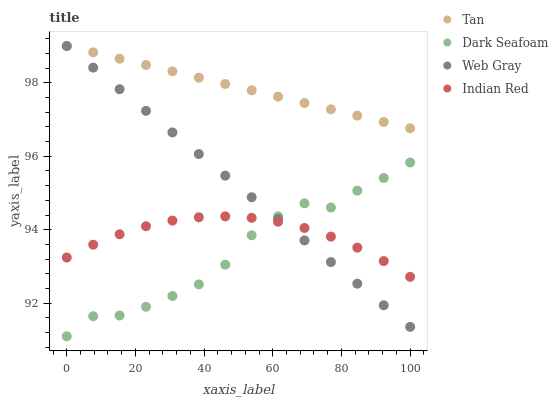Does Dark Seafoam have the minimum area under the curve?
Answer yes or no. Yes. Does Tan have the maximum area under the curve?
Answer yes or no. Yes. Does Web Gray have the minimum area under the curve?
Answer yes or no. No. Does Web Gray have the maximum area under the curve?
Answer yes or no. No. Is Web Gray the smoothest?
Answer yes or no. Yes. Is Dark Seafoam the roughest?
Answer yes or no. Yes. Is Dark Seafoam the smoothest?
Answer yes or no. No. Is Web Gray the roughest?
Answer yes or no. No. Does Dark Seafoam have the lowest value?
Answer yes or no. Yes. Does Web Gray have the lowest value?
Answer yes or no. No. Does Web Gray have the highest value?
Answer yes or no. Yes. Does Dark Seafoam have the highest value?
Answer yes or no. No. Is Indian Red less than Tan?
Answer yes or no. Yes. Is Tan greater than Dark Seafoam?
Answer yes or no. Yes. Does Dark Seafoam intersect Indian Red?
Answer yes or no. Yes. Is Dark Seafoam less than Indian Red?
Answer yes or no. No. Is Dark Seafoam greater than Indian Red?
Answer yes or no. No. Does Indian Red intersect Tan?
Answer yes or no. No. 